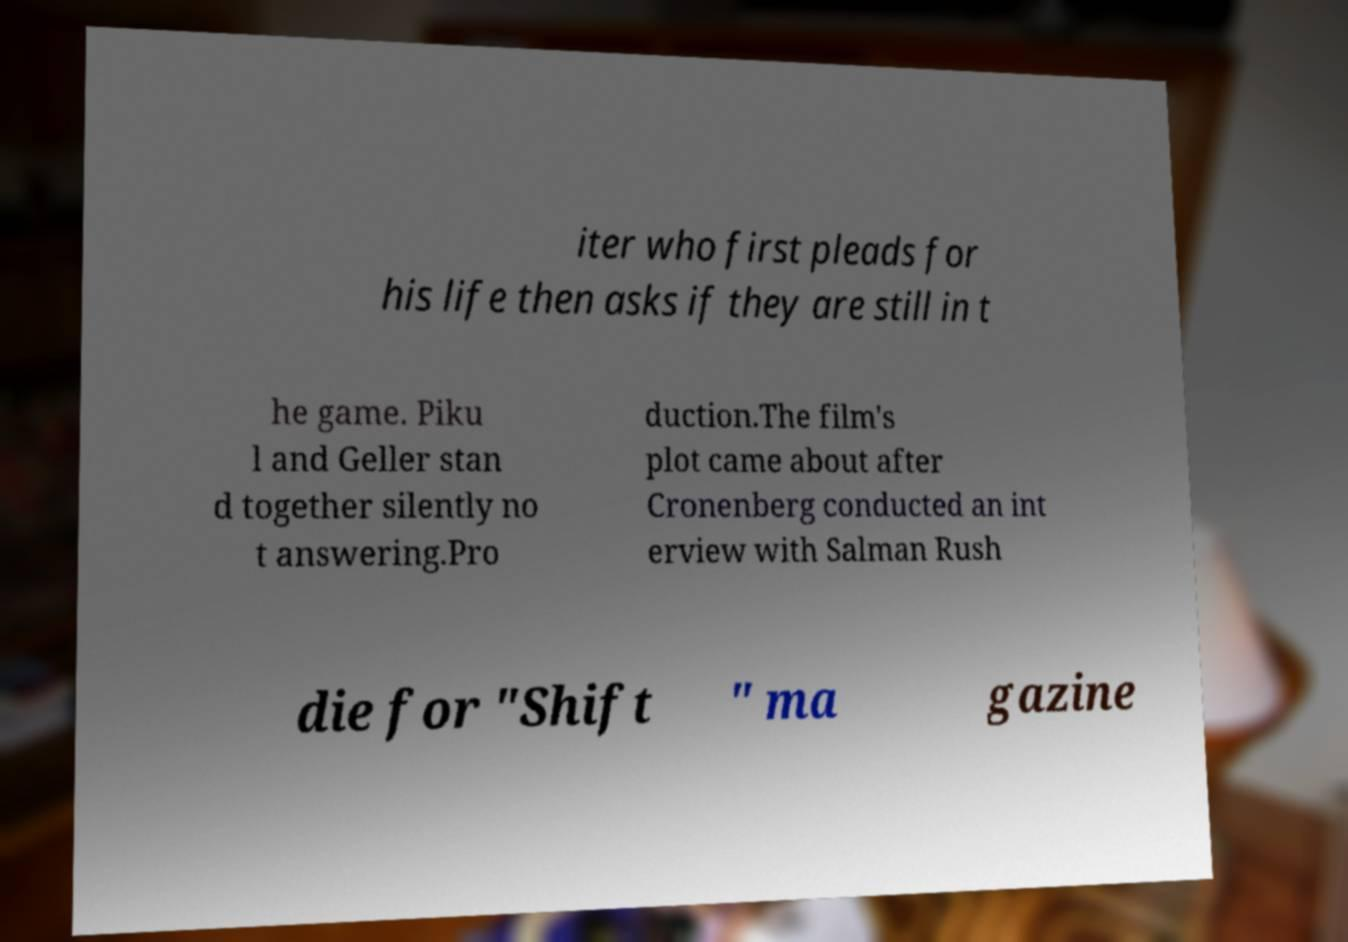Can you accurately transcribe the text from the provided image for me? iter who first pleads for his life then asks if they are still in t he game. Piku l and Geller stan d together silently no t answering.Pro duction.The film's plot came about after Cronenberg conducted an int erview with Salman Rush die for "Shift " ma gazine 